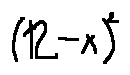<formula> <loc_0><loc_0><loc_500><loc_500>( 1 2 - x ) ^ { 2 }</formula> 